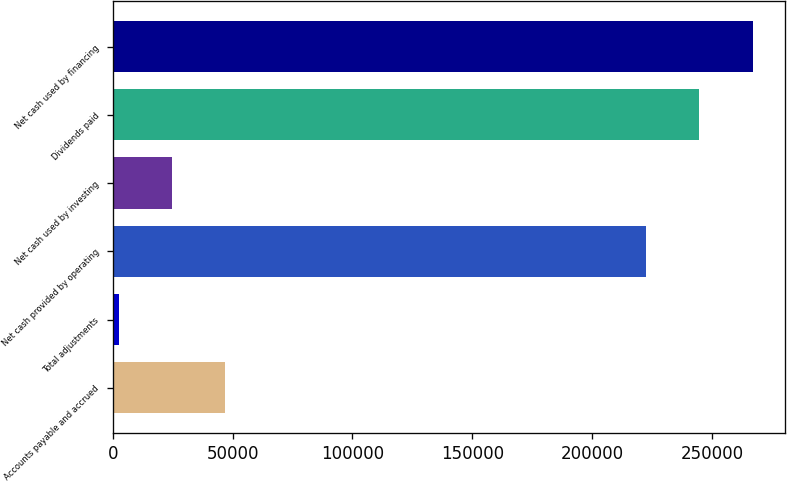Convert chart. <chart><loc_0><loc_0><loc_500><loc_500><bar_chart><fcel>Accounts payable and accrued<fcel>Total adjustments<fcel>Net cash provided by operating<fcel>Net cash used by investing<fcel>Dividends paid<fcel>Net cash used by financing<nl><fcel>47010.4<fcel>2513<fcel>222487<fcel>24761.7<fcel>244736<fcel>266984<nl></chart> 